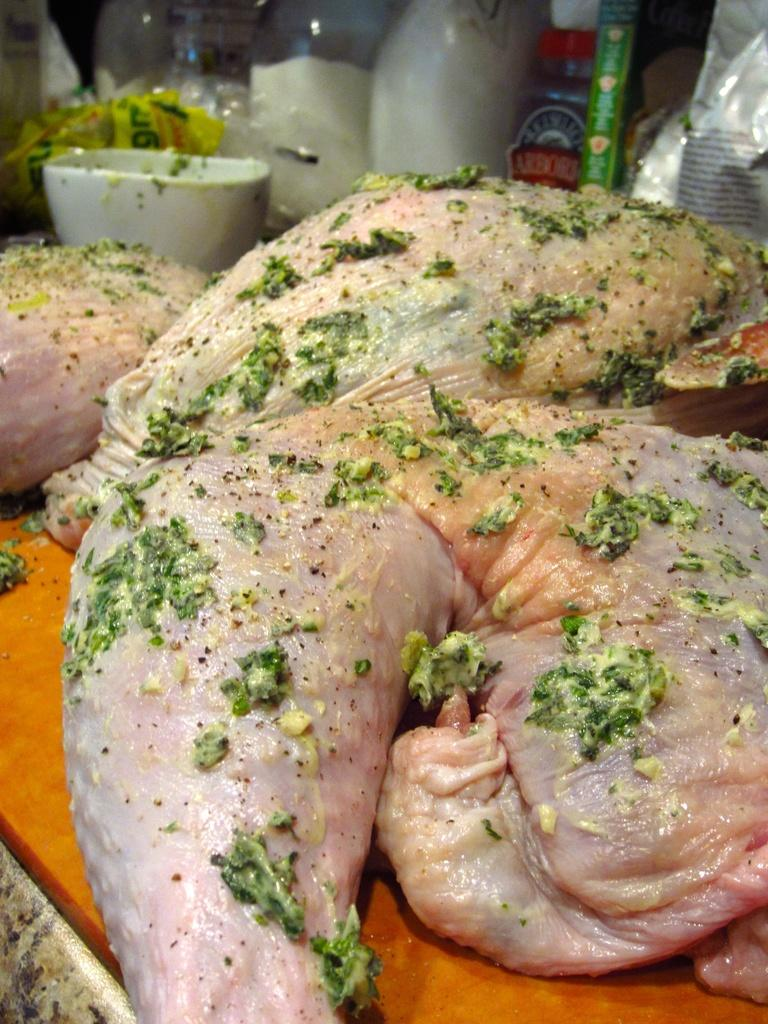What type of food is on the table in the image? There is meat on the table in the image. What else can be seen on the table besides the meat? There are bottles and a bowl on the table, as well as additional objects. What type of quartz is visible in the alley next to the table in the image? There is no quartz or alley present in the image; it only shows a table with meat, bottles, and a bowl. 